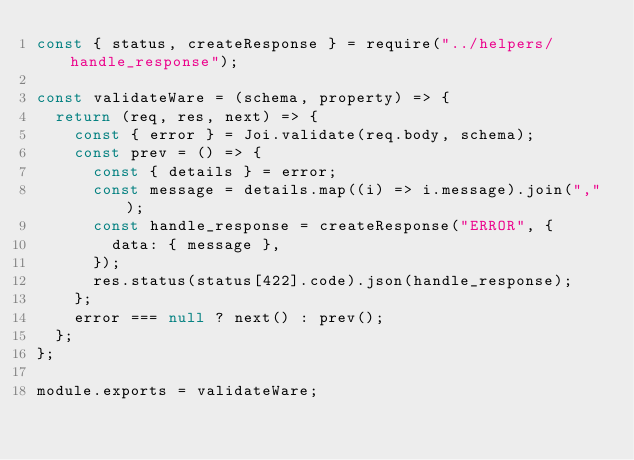Convert code to text. <code><loc_0><loc_0><loc_500><loc_500><_JavaScript_>const { status, createResponse } = require("../helpers/handle_response");

const validateWare = (schema, property) => {
  return (req, res, next) => {
    const { error } = Joi.validate(req.body, schema);
    const prev = () => {
      const { details } = error;
      const message = details.map((i) => i.message).join(",");
      const handle_response = createResponse("ERROR", {
        data: { message },
      });
      res.status(status[422].code).json(handle_response);
    };
    error === null ? next() : prev();
  };
};

module.exports = validateWare;
</code> 